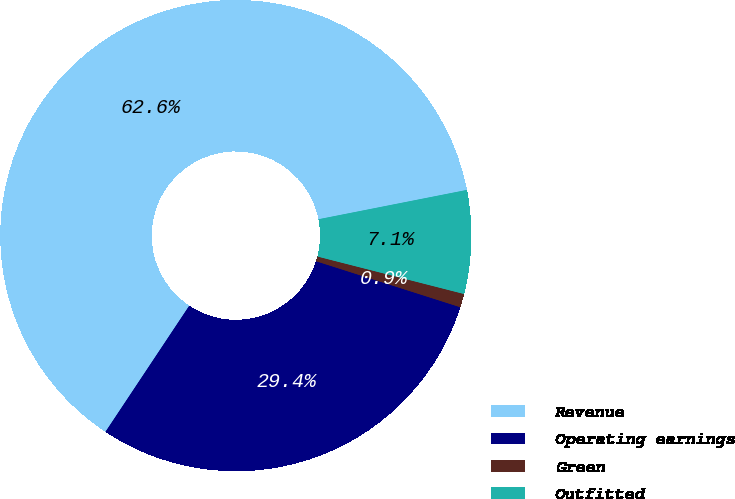Convert chart. <chart><loc_0><loc_0><loc_500><loc_500><pie_chart><fcel>Revenue<fcel>Operating earnings<fcel>Green<fcel>Outfitted<nl><fcel>62.56%<fcel>29.42%<fcel>0.93%<fcel>7.09%<nl></chart> 